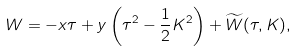Convert formula to latex. <formula><loc_0><loc_0><loc_500><loc_500>W = - x \tau + y \left ( \tau ^ { 2 } - \frac { 1 } { 2 } K ^ { 2 } \right ) + \widetilde { W } ( \tau , K ) ,</formula> 